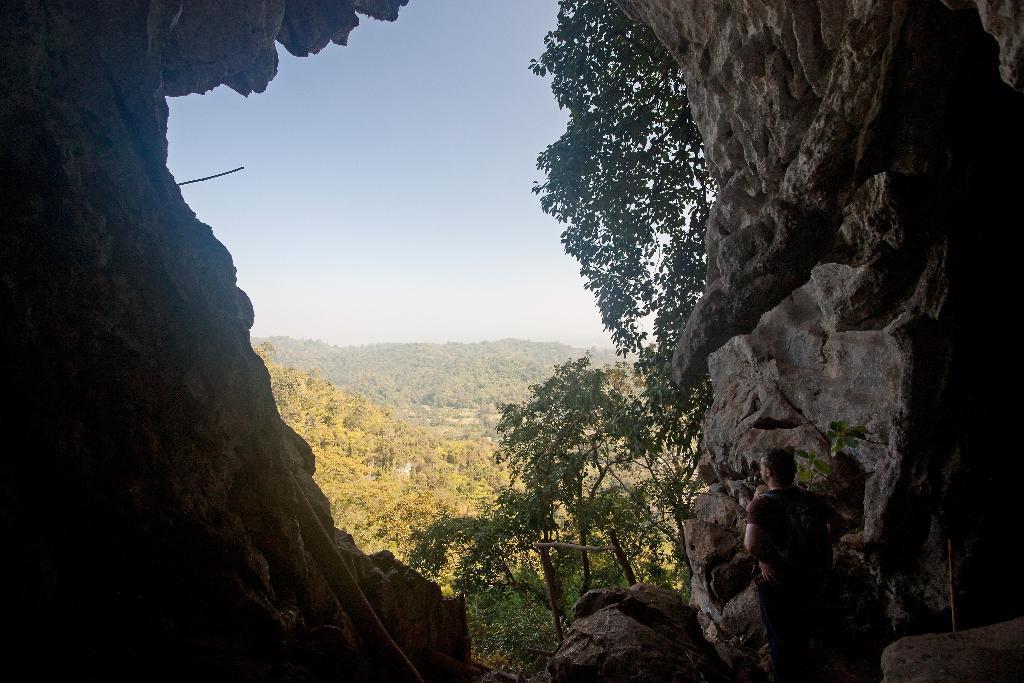Could you give a brief overview of what you see in this image? In this image we can see cave, person, trees, hills and sky. 